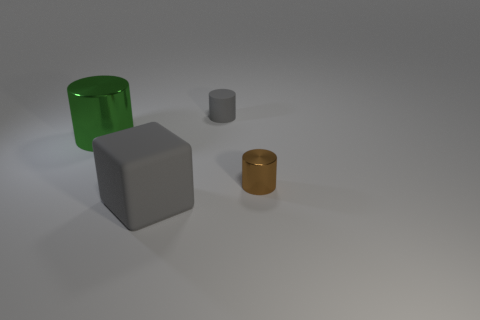How many other things are the same color as the tiny metal thing? In the image, there are no other objects that share the exact same color as the small, metallic item, which appears to have a distinct shade compared to the other items present. 